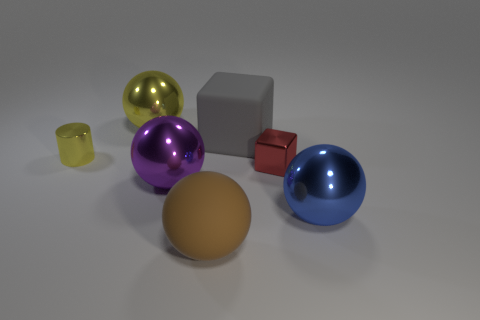Subtract all purple balls. How many balls are left? 3 Add 2 small yellow cylinders. How many objects exist? 9 Subtract all gray balls. Subtract all brown blocks. How many balls are left? 4 Subtract all blocks. How many objects are left? 5 Add 7 large metal balls. How many large metal balls exist? 10 Subtract 0 yellow cubes. How many objects are left? 7 Subtract all yellow rubber things. Subtract all big blocks. How many objects are left? 6 Add 3 big purple metal things. How many big purple metal things are left? 4 